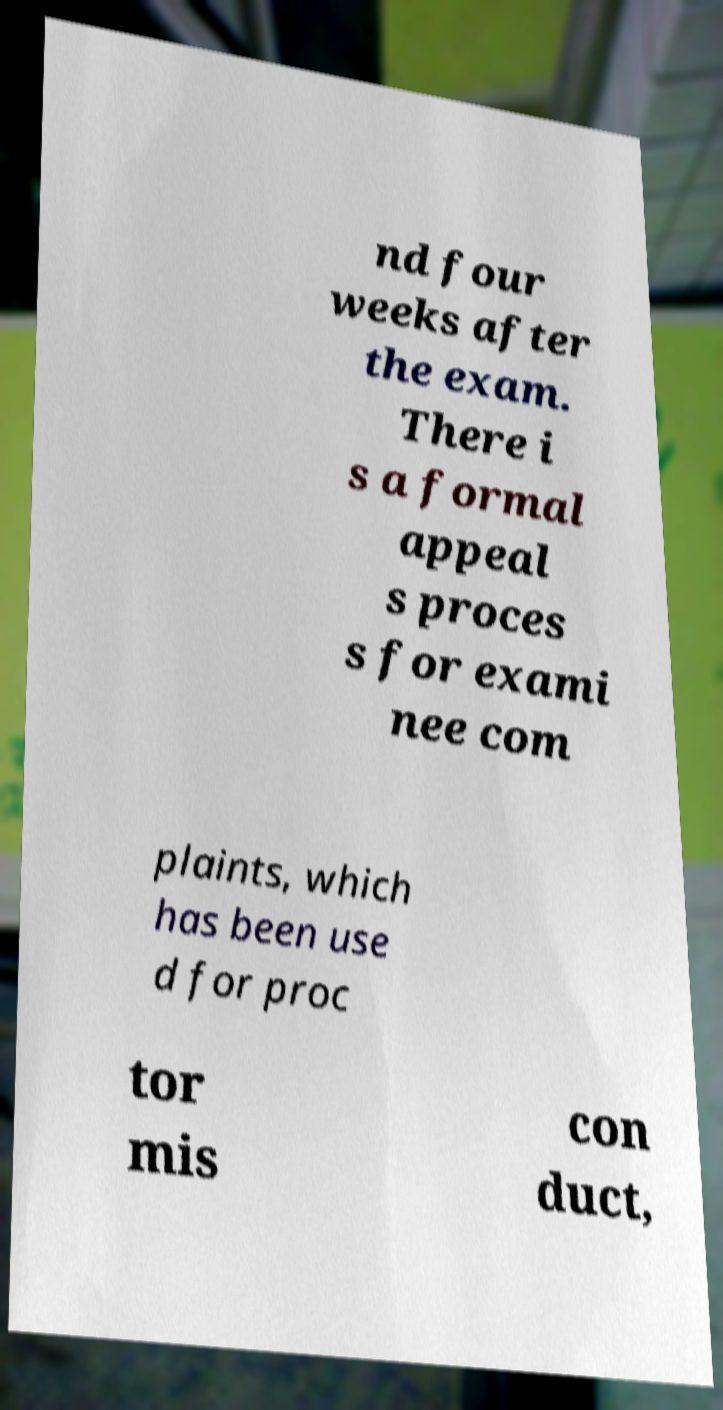I need the written content from this picture converted into text. Can you do that? nd four weeks after the exam. There i s a formal appeal s proces s for exami nee com plaints, which has been use d for proc tor mis con duct, 